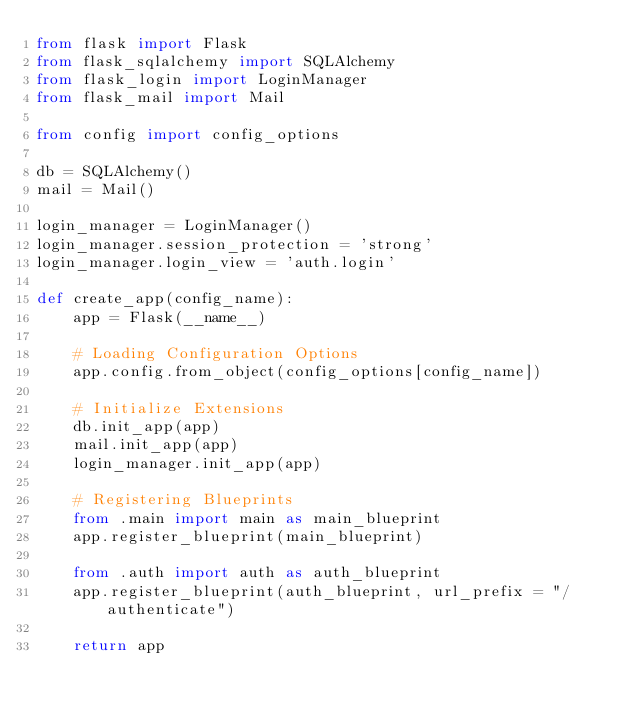<code> <loc_0><loc_0><loc_500><loc_500><_Python_>from flask import Flask
from flask_sqlalchemy import SQLAlchemy
from flask_login import LoginManager
from flask_mail import Mail

from config import config_options

db = SQLAlchemy()
mail = Mail()

login_manager = LoginManager()
login_manager.session_protection = 'strong'
login_manager.login_view = 'auth.login'

def create_app(config_name):
    app = Flask(__name__)

    # Loading Configuration Options
    app.config.from_object(config_options[config_name])

    # Initialize Extensions
    db.init_app(app)
    mail.init_app(app)
    login_manager.init_app(app)
    
    # Registering Blueprints
    from .main import main as main_blueprint
    app.register_blueprint(main_blueprint)

    from .auth import auth as auth_blueprint
    app.register_blueprint(auth_blueprint, url_prefix = "/authenticate")

    return app</code> 